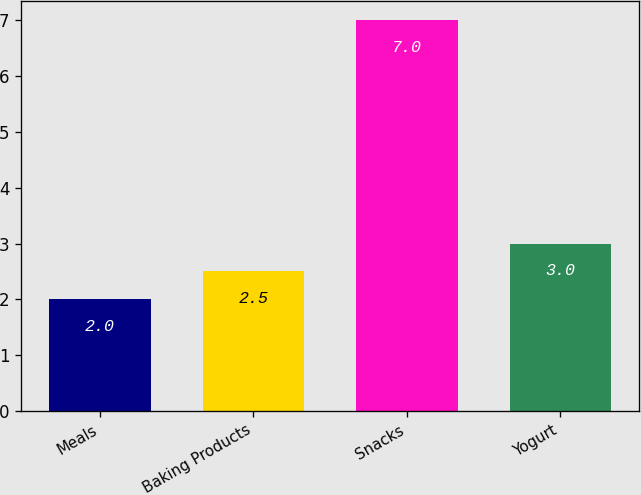Convert chart to OTSL. <chart><loc_0><loc_0><loc_500><loc_500><bar_chart><fcel>Meals<fcel>Baking Products<fcel>Snacks<fcel>Yogurt<nl><fcel>2<fcel>2.5<fcel>7<fcel>3<nl></chart> 